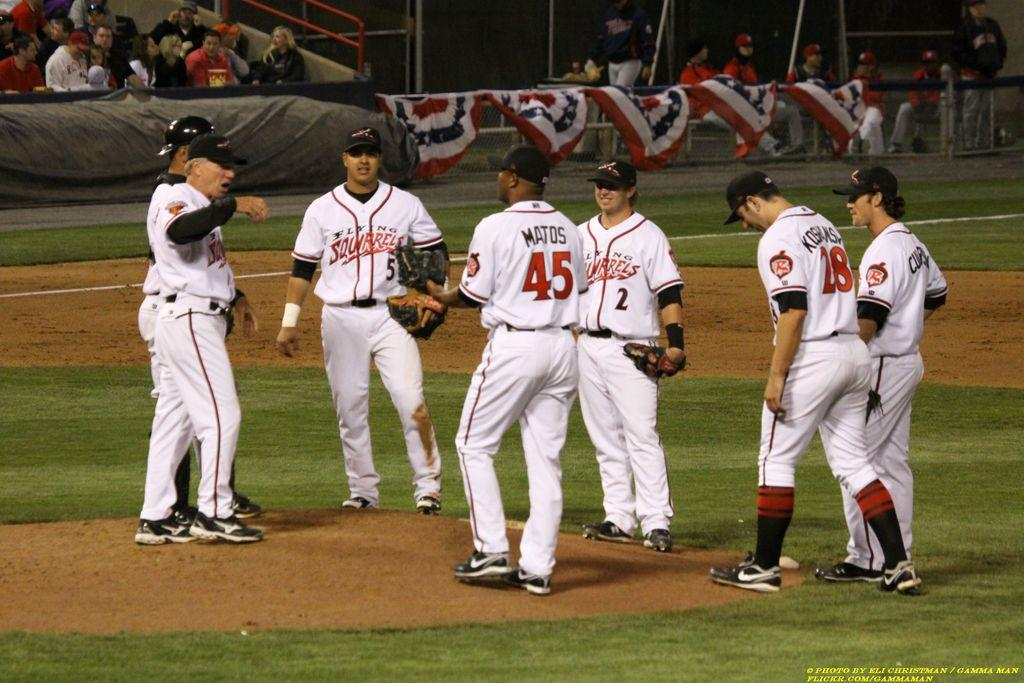<image>
Offer a succinct explanation of the picture presented. Members of the Flying Squirrels baseball team gather on the mound. 